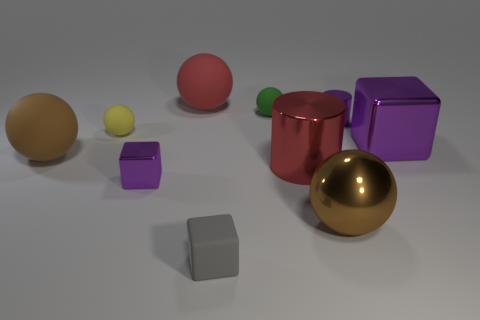Subtract all large purple cubes. How many cubes are left? 2 Subtract all brown spheres. How many spheres are left? 3 Subtract 5 spheres. How many spheres are left? 0 Subtract all cubes. How many objects are left? 7 Subtract all blue cylinders. How many purple cubes are left? 2 Subtract all red cylinders. Subtract all green spheres. How many cylinders are left? 1 Subtract all small purple rubber cylinders. Subtract all tiny purple metallic things. How many objects are left? 8 Add 8 tiny purple metallic cylinders. How many tiny purple metallic cylinders are left? 9 Add 1 big purple shiny objects. How many big purple shiny objects exist? 2 Subtract 0 green cubes. How many objects are left? 10 